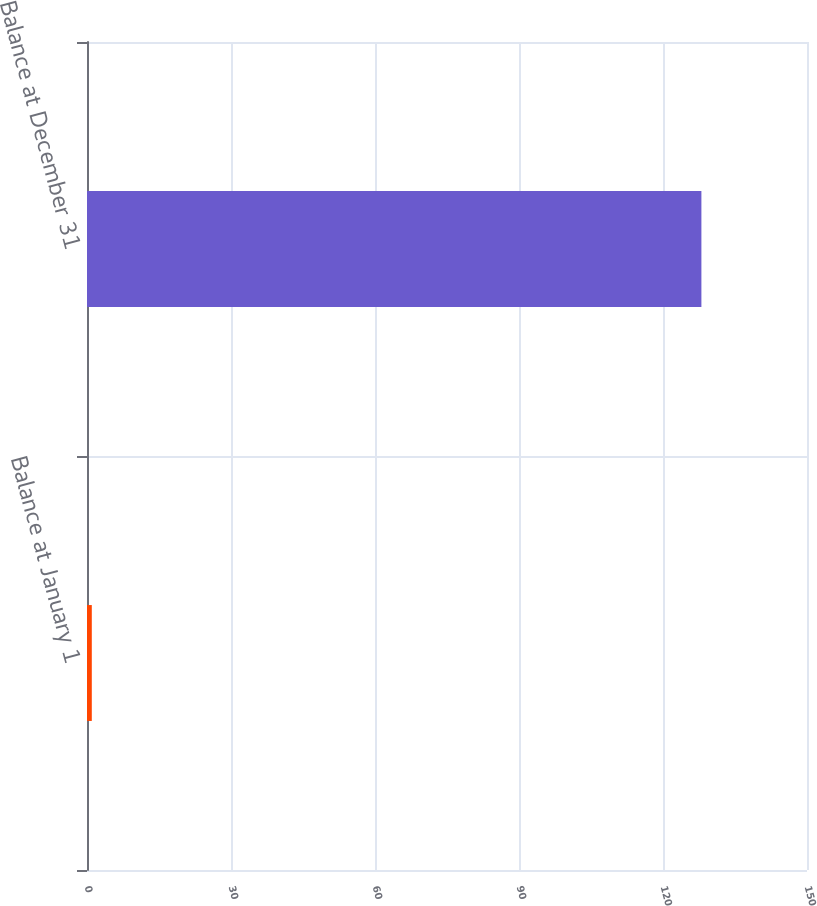Convert chart. <chart><loc_0><loc_0><loc_500><loc_500><bar_chart><fcel>Balance at January 1<fcel>Balance at December 31<nl><fcel>1<fcel>128<nl></chart> 